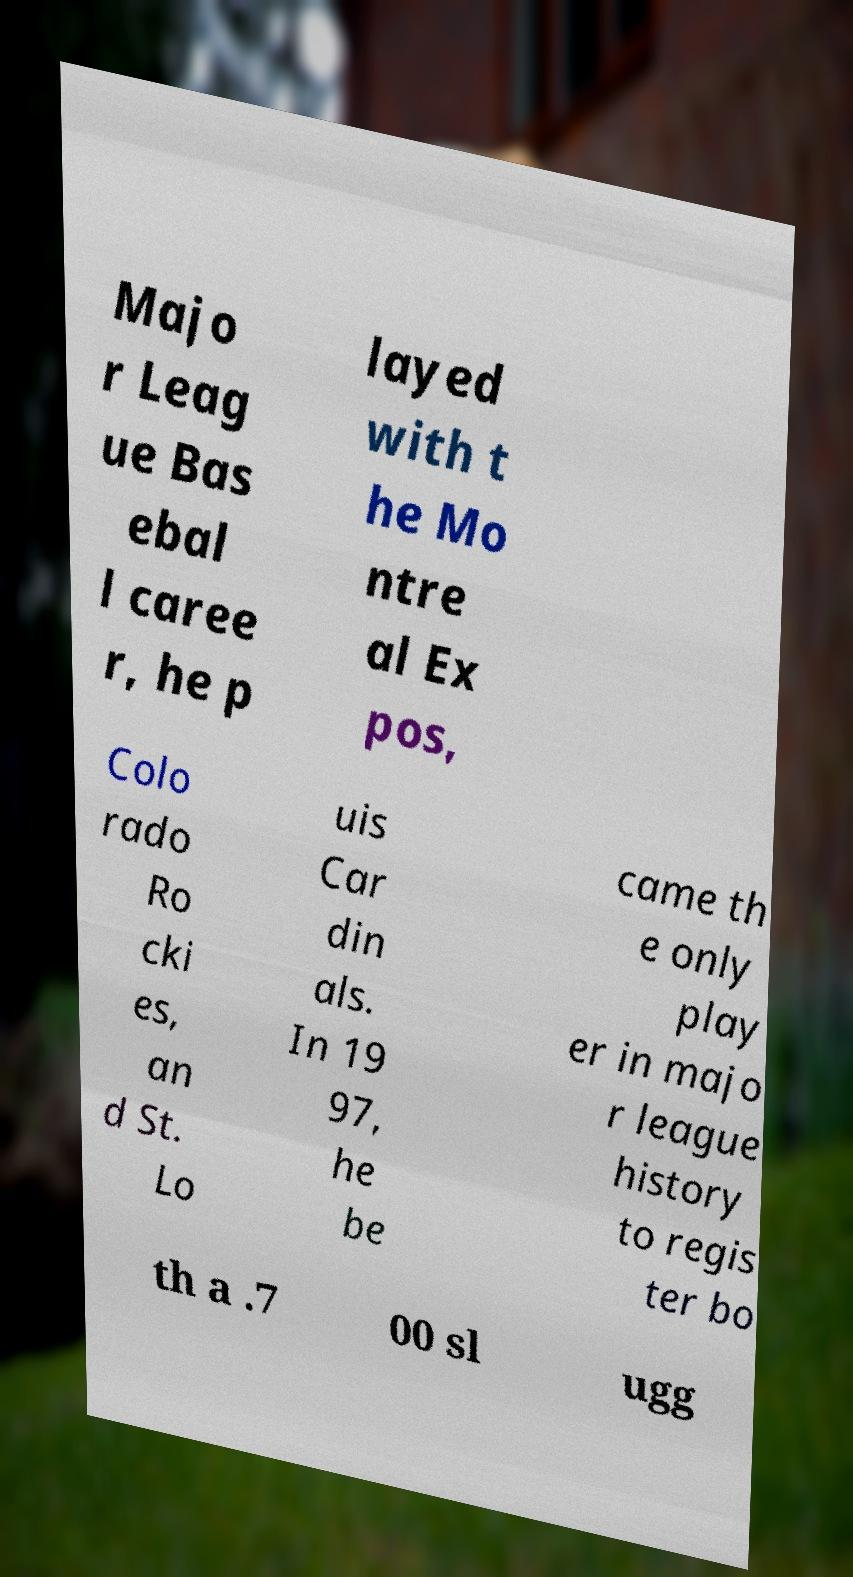I need the written content from this picture converted into text. Can you do that? Majo r Leag ue Bas ebal l caree r, he p layed with t he Mo ntre al Ex pos, Colo rado Ro cki es, an d St. Lo uis Car din als. In 19 97, he be came th e only play er in majo r league history to regis ter bo th a .7 00 sl ugg 